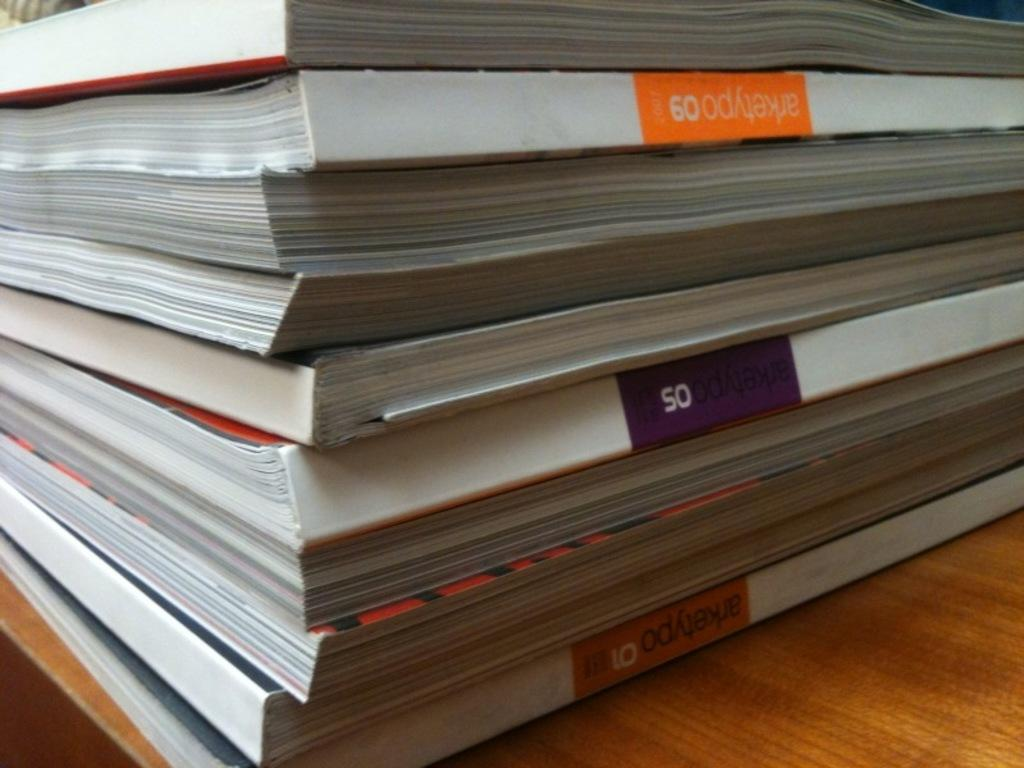Provide a one-sentence caption for the provided image. A book about arketypo 09 sits with several other books in a stack. 